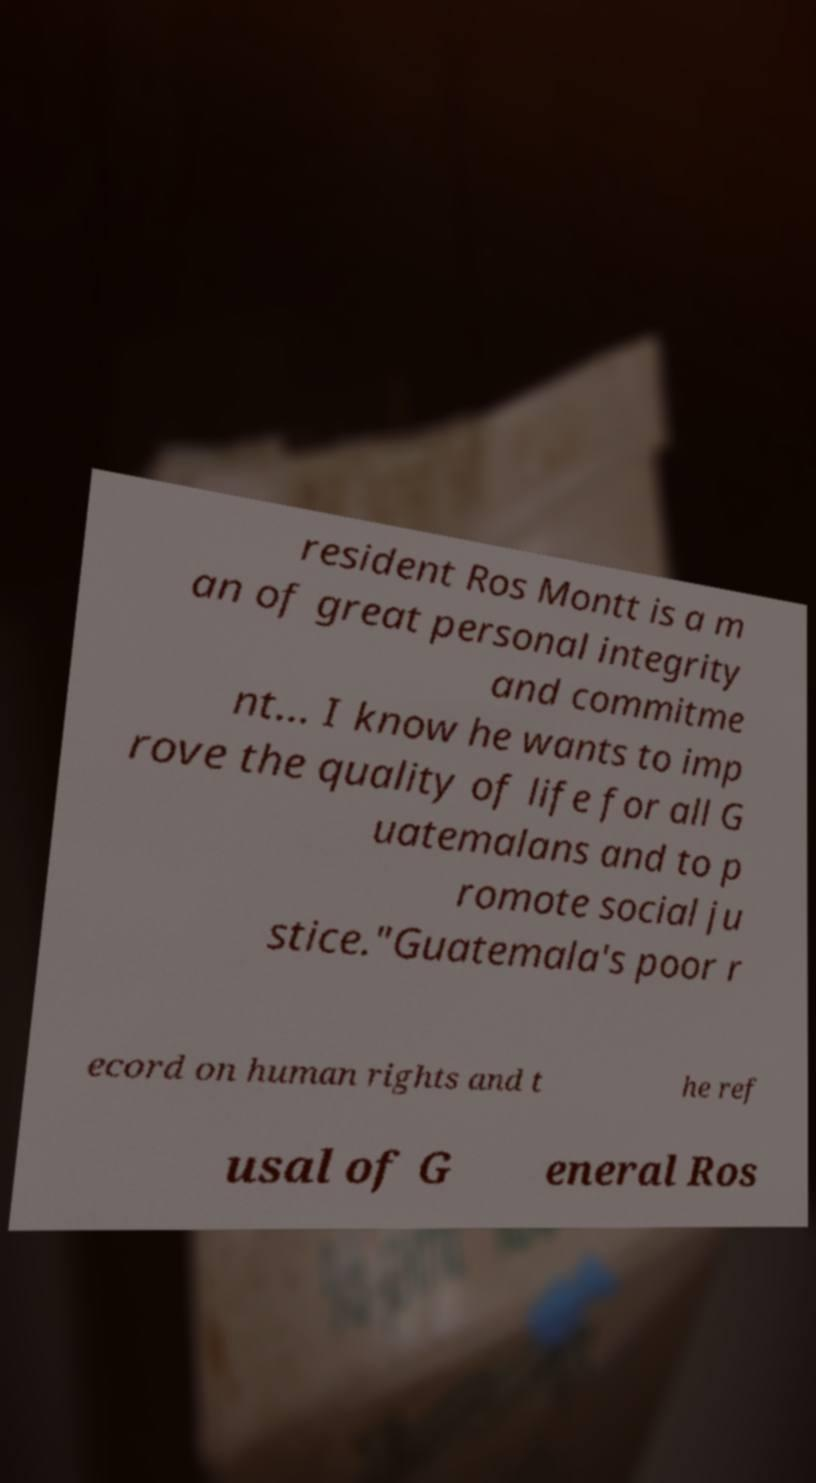Could you assist in decoding the text presented in this image and type it out clearly? resident Ros Montt is a m an of great personal integrity and commitme nt... I know he wants to imp rove the quality of life for all G uatemalans and to p romote social ju stice."Guatemala's poor r ecord on human rights and t he ref usal of G eneral Ros 